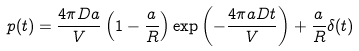Convert formula to latex. <formula><loc_0><loc_0><loc_500><loc_500>p ( t ) = \frac { 4 \pi D a } { V } \left ( 1 - \frac { a } R \right ) \exp \left ( - \frac { 4 \pi a D t } { V } \right ) + \frac { a } { R } \delta ( t )</formula> 